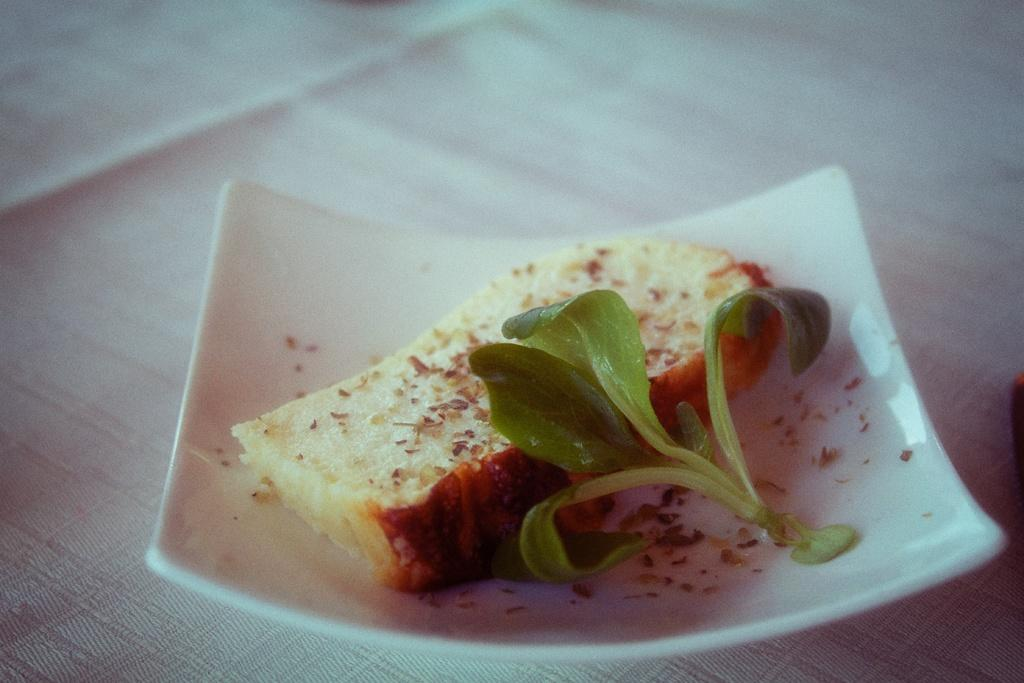What type of food can be seen in the image? The food in the image has cream, brown, and green colors. What is the food placed on in the image? The food is placed on a plate in the image. What is the color of the cloth that the plate is on? The plate is on a white cloth in the image. Can you see any veins in the food in the image? There are no veins present in the food in the image, as veins are typically found in living organisms and not in food items. 